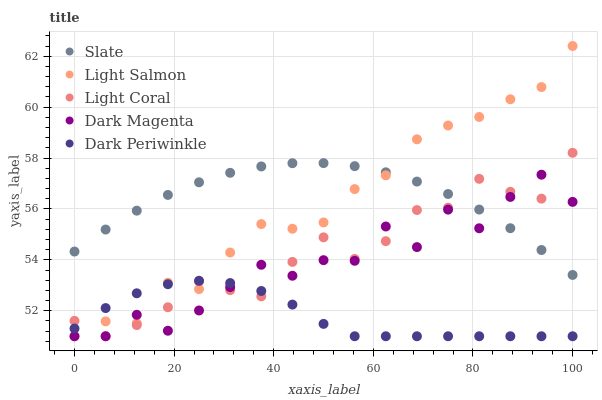Does Dark Periwinkle have the minimum area under the curve?
Answer yes or no. Yes. Does Slate have the maximum area under the curve?
Answer yes or no. Yes. Does Slate have the minimum area under the curve?
Answer yes or no. No. Does Dark Periwinkle have the maximum area under the curve?
Answer yes or no. No. Is Slate the smoothest?
Answer yes or no. Yes. Is Dark Magenta the roughest?
Answer yes or no. Yes. Is Dark Periwinkle the smoothest?
Answer yes or no. No. Is Dark Periwinkle the roughest?
Answer yes or no. No. Does Light Coral have the lowest value?
Answer yes or no. Yes. Does Slate have the lowest value?
Answer yes or no. No. Does Light Salmon have the highest value?
Answer yes or no. Yes. Does Slate have the highest value?
Answer yes or no. No. Is Dark Periwinkle less than Slate?
Answer yes or no. Yes. Is Slate greater than Dark Periwinkle?
Answer yes or no. Yes. Does Slate intersect Light Salmon?
Answer yes or no. Yes. Is Slate less than Light Salmon?
Answer yes or no. No. Is Slate greater than Light Salmon?
Answer yes or no. No. Does Dark Periwinkle intersect Slate?
Answer yes or no. No. 